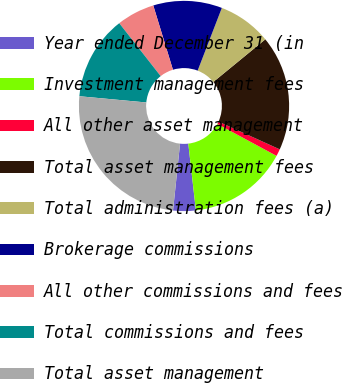Convert chart to OTSL. <chart><loc_0><loc_0><loc_500><loc_500><pie_chart><fcel>Year ended December 31 (in<fcel>Investment management fees<fcel>All other asset management<fcel>Total asset management fees<fcel>Total administration fees (a)<fcel>Brokerage commissions<fcel>All other commissions and fees<fcel>Total commissions and fees<fcel>Total asset management<nl><fcel>3.47%<fcel>15.32%<fcel>1.1%<fcel>17.69%<fcel>8.21%<fcel>10.58%<fcel>5.84%<fcel>12.95%<fcel>24.8%<nl></chart> 